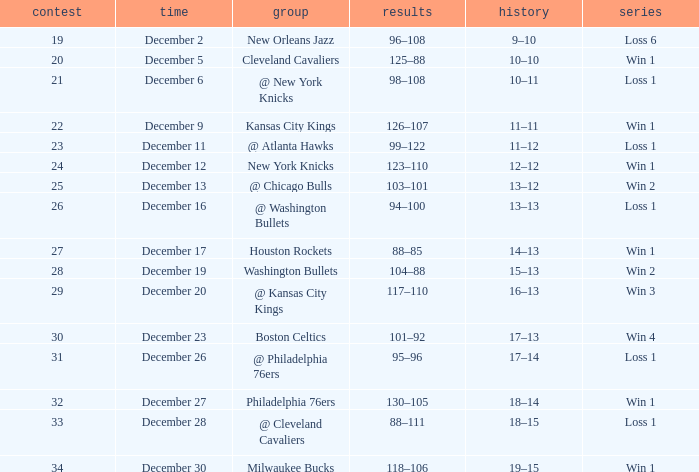What Game had a Score of 101–92? 30.0. 